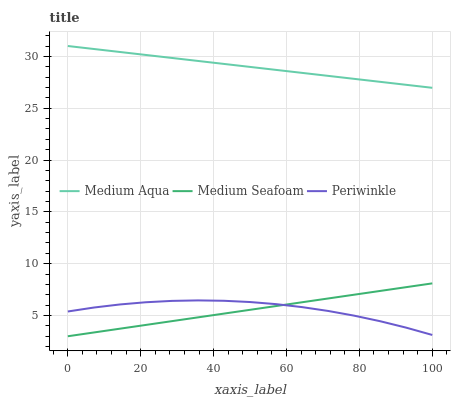Does Medium Aqua have the minimum area under the curve?
Answer yes or no. No. Does Medium Seafoam have the maximum area under the curve?
Answer yes or no. No. Is Medium Aqua the smoothest?
Answer yes or no. No. Is Medium Aqua the roughest?
Answer yes or no. No. Does Medium Aqua have the lowest value?
Answer yes or no. No. Does Medium Seafoam have the highest value?
Answer yes or no. No. Is Medium Seafoam less than Medium Aqua?
Answer yes or no. Yes. Is Medium Aqua greater than Periwinkle?
Answer yes or no. Yes. Does Medium Seafoam intersect Medium Aqua?
Answer yes or no. No. 